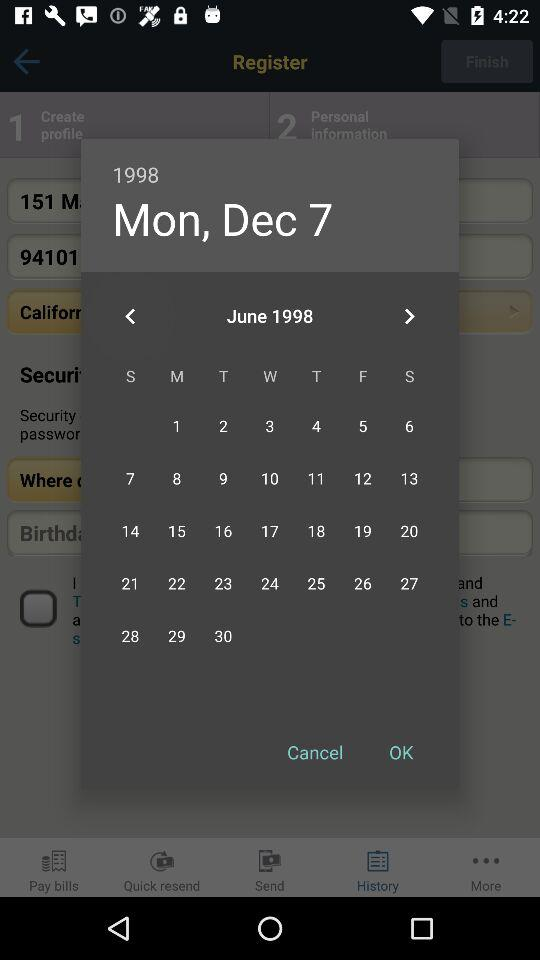What is the selected date? The selected date is Monday, December 7, 1998. 